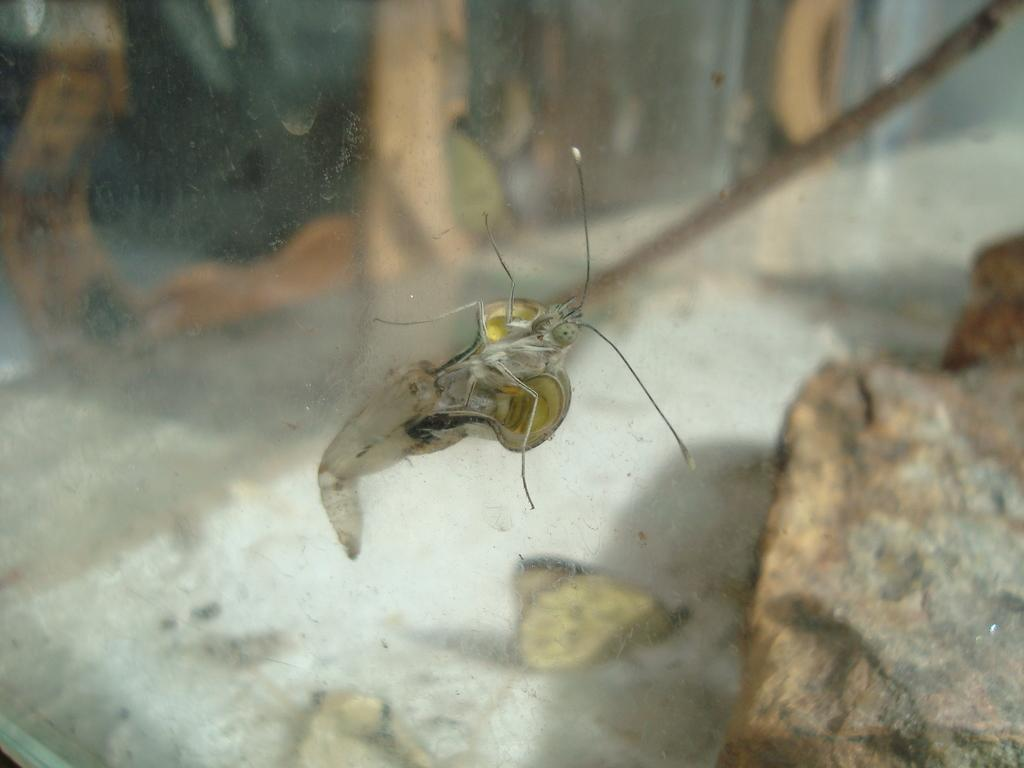What is the main subject in the middle of the image? There is an insect in the middle of the image. What can be seen at the bottom of the image? There is a stone at the bottom of the image. What type of creatures can be seen on the floor in the image? There are butterflies on the floor in the image. What type of furniture is visible in the background of the image? There is a wooden table in the background of the image. What time of day is it in the image, considering the presence of a flower? There is no flower present in the image, so it is not possible to determine the time of day based on that information. 